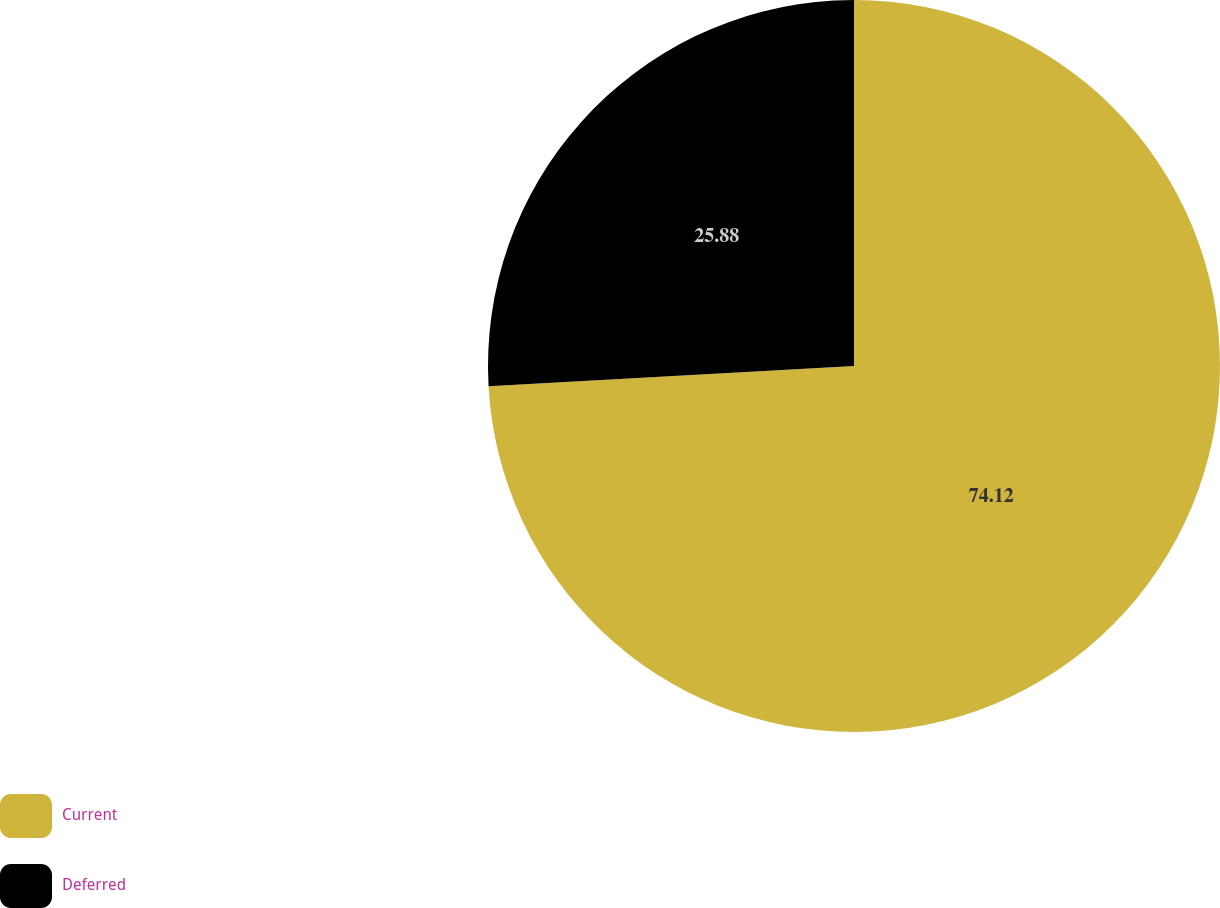Convert chart to OTSL. <chart><loc_0><loc_0><loc_500><loc_500><pie_chart><fcel>Current<fcel>Deferred<nl><fcel>74.12%<fcel>25.88%<nl></chart> 